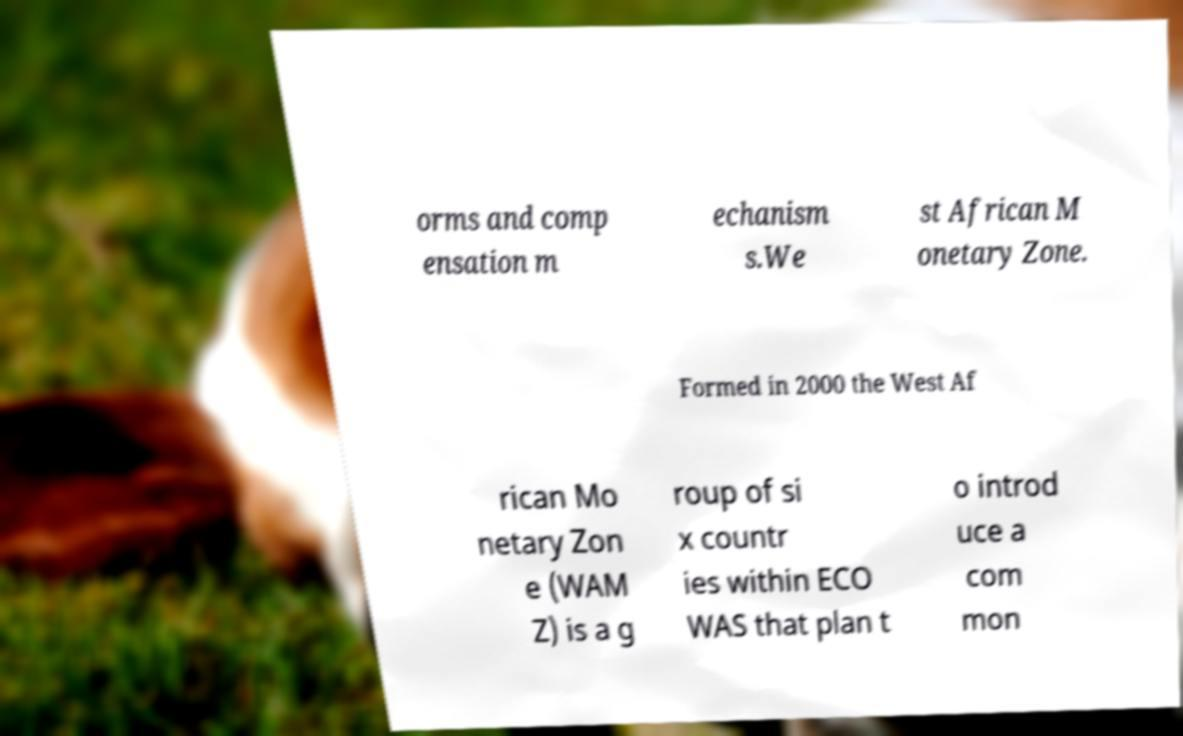For documentation purposes, I need the text within this image transcribed. Could you provide that? orms and comp ensation m echanism s.We st African M onetary Zone. Formed in 2000 the West Af rican Mo netary Zon e (WAM Z) is a g roup of si x countr ies within ECO WAS that plan t o introd uce a com mon 